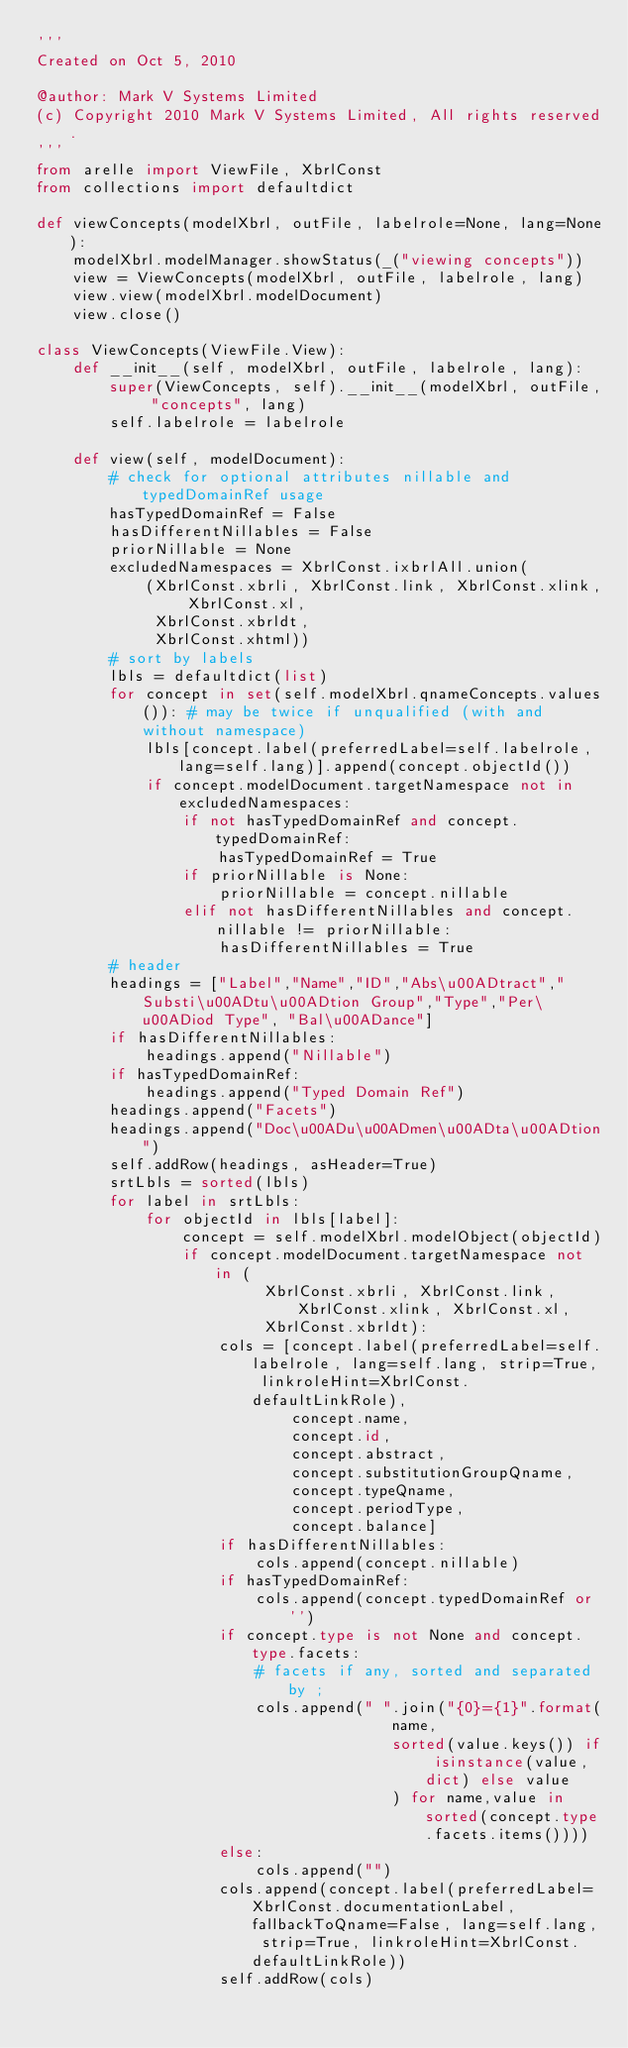Convert code to text. <code><loc_0><loc_0><loc_500><loc_500><_Python_>'''
Created on Oct 5, 2010

@author: Mark V Systems Limited
(c) Copyright 2010 Mark V Systems Limited, All rights reserved.
'''
from arelle import ViewFile, XbrlConst
from collections import defaultdict

def viewConcepts(modelXbrl, outFile, labelrole=None, lang=None):
    modelXbrl.modelManager.showStatus(_("viewing concepts"))
    view = ViewConcepts(modelXbrl, outFile, labelrole, lang)
    view.view(modelXbrl.modelDocument)
    view.close()
    
class ViewConcepts(ViewFile.View):
    def __init__(self, modelXbrl, outFile, labelrole, lang):
        super(ViewConcepts, self).__init__(modelXbrl, outFile, "concepts", lang)
        self.labelrole = labelrole
        
    def view(self, modelDocument):
        # check for optional attributes nillable and typedDomainRef usage
        hasTypedDomainRef = False
        hasDifferentNillables = False
        priorNillable = None
        excludedNamespaces = XbrlConst.ixbrlAll.union(
            (XbrlConst.xbrli, XbrlConst.link, XbrlConst.xlink, XbrlConst.xl,
             XbrlConst.xbrldt,
             XbrlConst.xhtml))
        # sort by labels
        lbls = defaultdict(list)
        for concept in set(self.modelXbrl.qnameConcepts.values()): # may be twice if unqualified (with and without namespace)
            lbls[concept.label(preferredLabel=self.labelrole, lang=self.lang)].append(concept.objectId())
            if concept.modelDocument.targetNamespace not in excludedNamespaces:
                if not hasTypedDomainRef and concept.typedDomainRef:
                    hasTypedDomainRef = True
                if priorNillable is None:
                    priorNillable = concept.nillable
                elif not hasDifferentNillables and concept.nillable != priorNillable:
                    hasDifferentNillables = True
        # header
        headings = ["Label","Name","ID","Abs\u00ADtract","Substi\u00ADtu\u00ADtion Group","Type","Per\u00ADiod Type", "Bal\u00ADance"]
        if hasDifferentNillables:
            headings.append("Nillable")
        if hasTypedDomainRef:
            headings.append("Typed Domain Ref")
        headings.append("Facets")
        headings.append("Doc\u00ADu\u00ADmen\u00ADta\u00ADtion")
        self.addRow(headings, asHeader=True)
        srtLbls = sorted(lbls)
        for label in srtLbls:
            for objectId in lbls[label]:
                concept = self.modelXbrl.modelObject(objectId)
                if concept.modelDocument.targetNamespace not in (
                         XbrlConst.xbrli, XbrlConst.link, XbrlConst.xlink, XbrlConst.xl,
                         XbrlConst.xbrldt):
                    cols = [concept.label(preferredLabel=self.labelrole, lang=self.lang, strip=True, linkroleHint=XbrlConst.defaultLinkRole),
                            concept.name,
                            concept.id,
                            concept.abstract,
                            concept.substitutionGroupQname,
                            concept.typeQname,
                            concept.periodType,
                            concept.balance]
                    if hasDifferentNillables:
                        cols.append(concept.nillable)
                    if hasTypedDomainRef:
                        cols.append(concept.typedDomainRef or '')
                    if concept.type is not None and concept.type.facets:
                        # facets if any, sorted and separated by ;
                        cols.append(" ".join("{0}={1}".format(
                                       name,
                                       sorted(value.keys()) if isinstance(value,dict) else value
                                       ) for name,value in sorted(concept.type.facets.items())))
                    else:
                        cols.append("")
                    cols.append(concept.label(preferredLabel=XbrlConst.documentationLabel, fallbackToQname=False, lang=self.lang, strip=True, linkroleHint=XbrlConst.defaultLinkRole))
                    self.addRow(cols)
</code> 